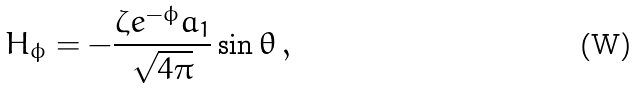Convert formula to latex. <formula><loc_0><loc_0><loc_500><loc_500>H _ { \phi } = - \frac { \zeta e ^ { - \phi } a _ { 1 } } { \sqrt { 4 \pi } } \sin \theta \, ,</formula> 